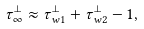Convert formula to latex. <formula><loc_0><loc_0><loc_500><loc_500>\tau _ { \infty } ^ { \perp } \approx \tau ^ { \perp } _ { w 1 } + \tau ^ { \perp } _ { w 2 } - 1 ,</formula> 